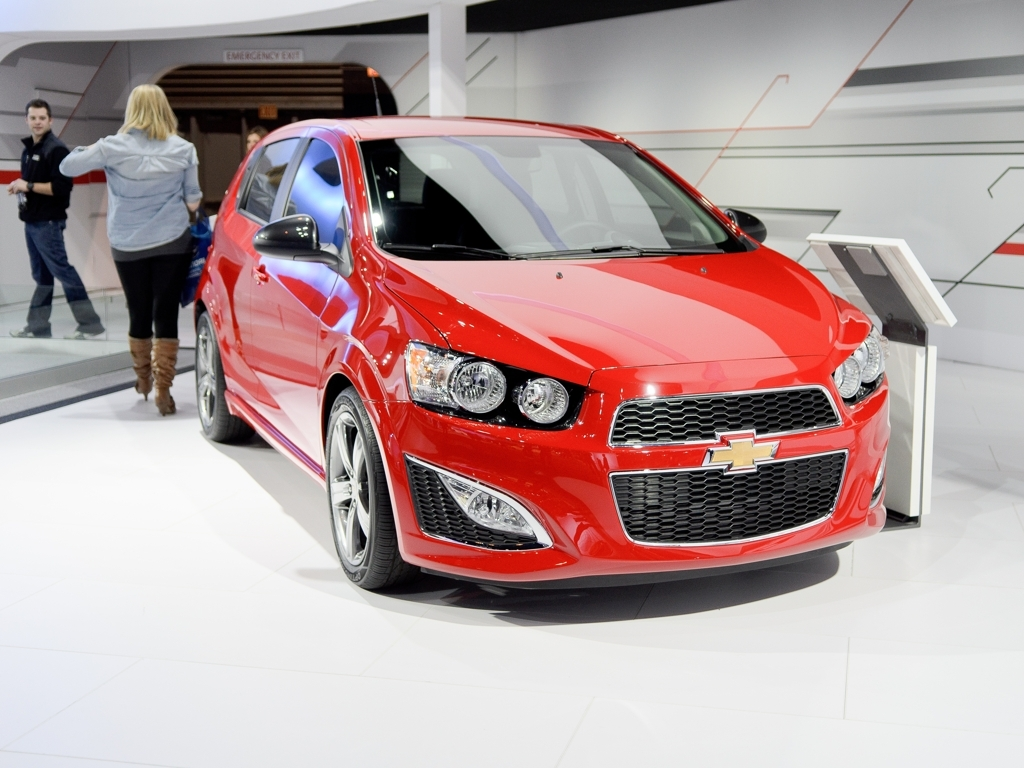Is the composition of the image good? The image has a strong composition, with the bright red car positioned in the center, drawing the viewer's focus immediately. Its placement against a contrasting, minimalistic background emphasizes the vehicle, while the direction of the lighting adds depth to the car's features and highlights its glossy finish. The angle of the photograph showcases the design of the car, including the chrome details and the shape of the headlights. Overall, the composition is thoughtfully arranged to highlight the car's aesthetics. 